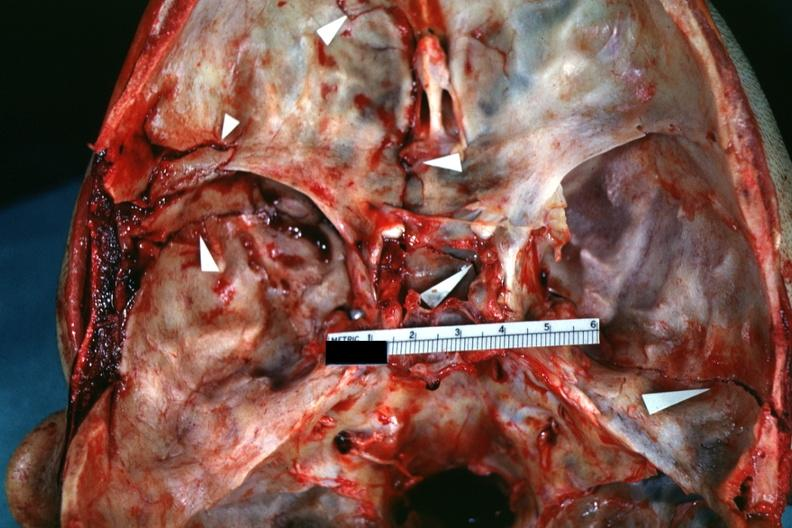s basilar skull fracture present?
Answer the question using a single word or phrase. Yes 